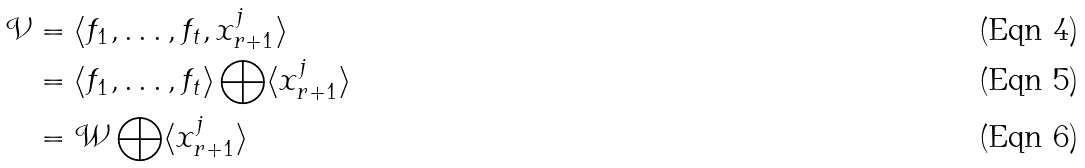Convert formula to latex. <formula><loc_0><loc_0><loc_500><loc_500>\mathcal { V } & = \langle f _ { 1 } , \dots , f _ { t } , x _ { r + 1 } ^ { j } \rangle \\ & = \langle f _ { 1 } , \dots , f _ { t } \rangle \bigoplus \langle x _ { r + 1 } ^ { j } \rangle \\ & = \mathcal { W } \bigoplus \langle x _ { r + 1 } ^ { j } \rangle</formula> 